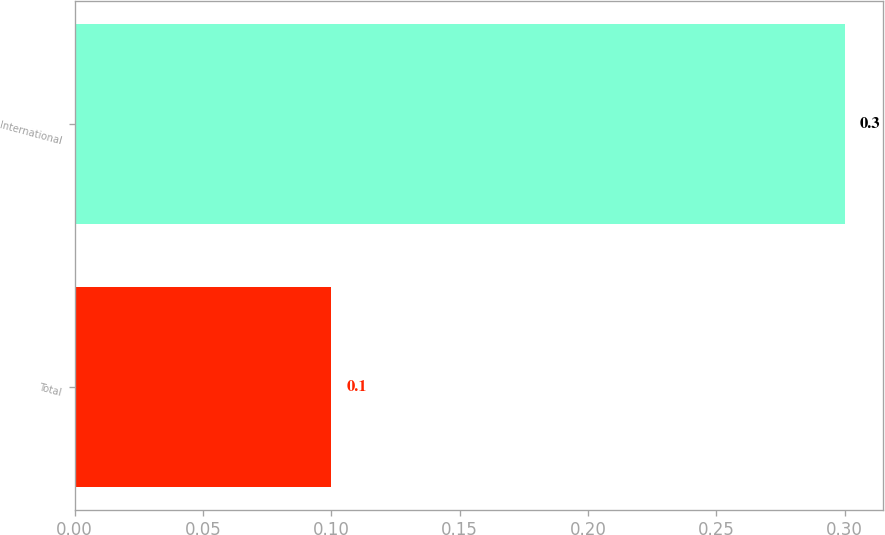<chart> <loc_0><loc_0><loc_500><loc_500><bar_chart><fcel>Total<fcel>International<nl><fcel>0.1<fcel>0.3<nl></chart> 